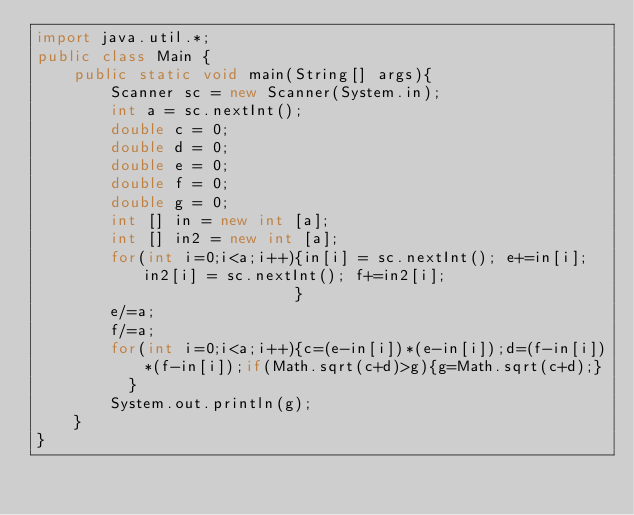Convert code to text. <code><loc_0><loc_0><loc_500><loc_500><_Java_>import java.util.*;
public class Main {
	public static void main(String[] args){
		Scanner sc = new Scanner(System.in);
		int a = sc.nextInt();
		double c = 0;
		double d = 0;
        double e = 0;
        double f = 0;
        double g = 0;
        int [] in = new int [a];
        int [] in2 = new int [a];
        for(int i=0;i<a;i++){in[i] = sc.nextInt(); e+=in[i]; in2[i] = sc.nextInt(); f+=in2[i];                             
                            }		        
        e/=a;
        f/=a;
        for(int i=0;i<a;i++){c=(e-in[i])*(e-in[i]);d=(f-in[i])*(f-in[i]);if(Math.sqrt(c+d)>g){g=Math.sqrt(c+d);}
          }
		System.out.println(g);
	}
}</code> 